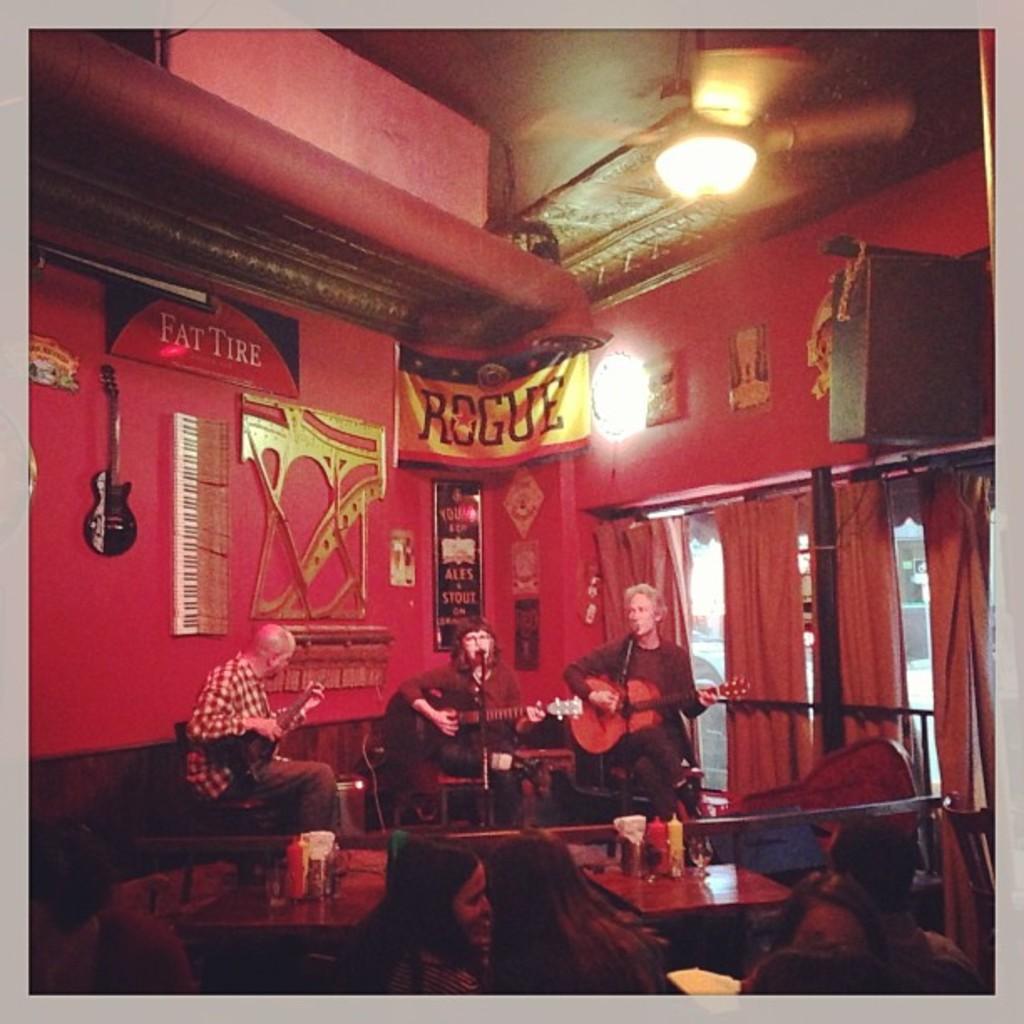Can you describe this image briefly? In the image we can see there are people who are sitting on chair and they are playing guitar in their hand. 